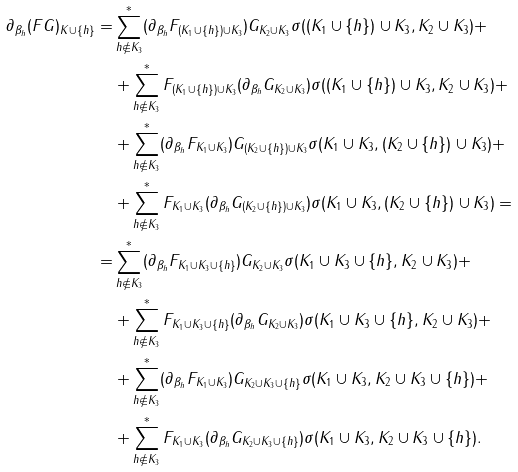Convert formula to latex. <formula><loc_0><loc_0><loc_500><loc_500>\partial _ { \beta _ { h } } ( F G ) _ { K \cup \{ h \} } = & \sum ^ { * } _ { h \not \in K _ { 3 } } ( \partial _ { \beta _ { h } } F _ { ( K _ { 1 } \cup \{ h \} ) \cup K _ { 3 } } ) G _ { K _ { 2 } \cup K _ { 3 } } \sigma ( ( K _ { 1 } \cup \{ h \} ) \cup K _ { 3 } , K _ { 2 } \cup K _ { 3 } ) + \\ & + \sum ^ { * } _ { h \not \in K _ { 3 } } F _ { ( K _ { 1 } \cup \{ h \} ) \cup K _ { 3 } } ( \partial _ { \beta _ { h } } G _ { K _ { 2 } \cup K _ { 3 } } ) \sigma ( ( K _ { 1 } \cup \{ h \} ) \cup K _ { 3 } , K _ { 2 } \cup K _ { 3 } ) + \\ & + \sum ^ { * } _ { h \not \in K _ { 3 } } ( \partial _ { \beta _ { h } } F _ { K _ { 1 } \cup K _ { 3 } } ) G _ { ( K _ { 2 } \cup \{ h \} ) \cup K _ { 3 } } \sigma ( K _ { 1 } \cup K _ { 3 } , ( K _ { 2 } \cup \{ h \} ) \cup K _ { 3 } ) + \\ & + \sum ^ { * } _ { h \not \in K _ { 3 } } F _ { K _ { 1 } \cup K _ { 3 } } ( \partial _ { \beta _ { h } } G _ { ( K _ { 2 } \cup \{ h \} ) \cup K _ { 3 } } ) \sigma ( K _ { 1 } \cup K _ { 3 } , ( K _ { 2 } \cup \{ h \} ) \cup K _ { 3 } ) = \\ = & \sum ^ { * } _ { h \not \in K _ { 3 } } ( \partial _ { \beta _ { h } } F _ { K _ { 1 } \cup K _ { 3 } \cup \{ h \} } ) G _ { K _ { 2 } \cup K _ { 3 } } \sigma ( K _ { 1 } \cup K _ { 3 } \cup \{ h \} , K _ { 2 } \cup K _ { 3 } ) + \\ & + \sum ^ { * } _ { h \not \in K _ { 3 } } F _ { K _ { 1 } \cup K _ { 3 } \cup \{ h \} } ( \partial _ { \beta _ { h } } G _ { K _ { 2 } \cup K _ { 3 } } ) \sigma ( K _ { 1 } \cup K _ { 3 } \cup \{ h \} , K _ { 2 } \cup K _ { 3 } ) + \\ & + \sum ^ { * } _ { h \not \in K _ { 3 } } ( \partial _ { \beta _ { h } } F _ { K _ { 1 } \cup K _ { 3 } } ) G _ { K _ { 2 } \cup K _ { 3 } \cup \{ h \} } \sigma ( K _ { 1 } \cup K _ { 3 } , K _ { 2 } \cup K _ { 3 } \cup \{ h \} ) + \\ & + \sum ^ { * } _ { h \not \in K _ { 3 } } F _ { K _ { 1 } \cup K _ { 3 } } ( \partial _ { \beta _ { h } } G _ { K _ { 2 } \cup K _ { 3 } \cup \{ h \} } ) \sigma ( K _ { 1 } \cup K _ { 3 } , K _ { 2 } \cup K _ { 3 } \cup \{ h \} ) .</formula> 